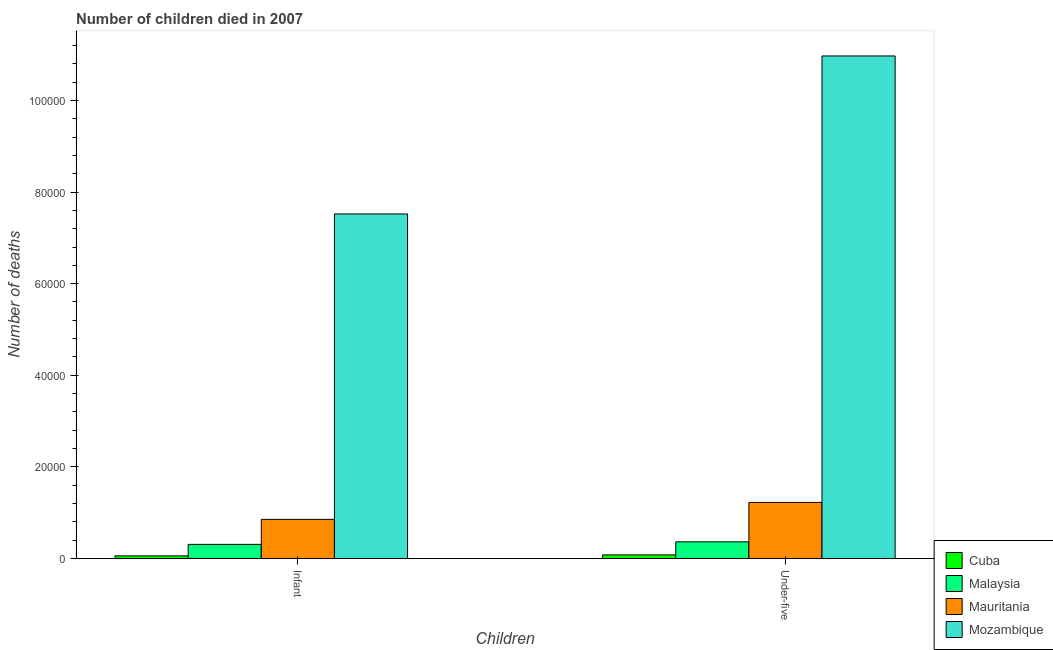Are the number of bars per tick equal to the number of legend labels?
Your answer should be very brief. Yes. What is the label of the 1st group of bars from the left?
Your answer should be very brief. Infant. What is the number of infant deaths in Cuba?
Give a very brief answer. 590. Across all countries, what is the maximum number of infant deaths?
Ensure brevity in your answer.  7.52e+04. Across all countries, what is the minimum number of infant deaths?
Keep it short and to the point. 590. In which country was the number of under-five deaths maximum?
Make the answer very short. Mozambique. In which country was the number of under-five deaths minimum?
Provide a short and direct response. Cuba. What is the total number of infant deaths in the graph?
Your response must be concise. 8.75e+04. What is the difference between the number of infant deaths in Malaysia and that in Mozambique?
Offer a very short reply. -7.21e+04. What is the difference between the number of infant deaths in Malaysia and the number of under-five deaths in Cuba?
Give a very brief answer. 2300. What is the average number of under-five deaths per country?
Give a very brief answer. 3.16e+04. What is the difference between the number of under-five deaths and number of infant deaths in Mauritania?
Offer a terse response. 3699. In how many countries, is the number of under-five deaths greater than 48000 ?
Your response must be concise. 1. What is the ratio of the number of infant deaths in Mauritania to that in Cuba?
Your response must be concise. 14.5. Is the number of infant deaths in Mauritania less than that in Cuba?
Your answer should be compact. No. In how many countries, is the number of under-five deaths greater than the average number of under-five deaths taken over all countries?
Make the answer very short. 1. What does the 1st bar from the left in Infant represents?
Keep it short and to the point. Cuba. What does the 4th bar from the right in Under-five represents?
Your answer should be very brief. Cuba. How many countries are there in the graph?
Your answer should be very brief. 4. Are the values on the major ticks of Y-axis written in scientific E-notation?
Provide a short and direct response. No. Where does the legend appear in the graph?
Give a very brief answer. Bottom right. How many legend labels are there?
Offer a terse response. 4. What is the title of the graph?
Provide a succinct answer. Number of children died in 2007. Does "Seychelles" appear as one of the legend labels in the graph?
Provide a short and direct response. No. What is the label or title of the X-axis?
Your response must be concise. Children. What is the label or title of the Y-axis?
Ensure brevity in your answer.  Number of deaths. What is the Number of deaths of Cuba in Infant?
Offer a very short reply. 590. What is the Number of deaths of Malaysia in Infant?
Keep it short and to the point. 3101. What is the Number of deaths in Mauritania in Infant?
Offer a very short reply. 8556. What is the Number of deaths of Mozambique in Infant?
Ensure brevity in your answer.  7.52e+04. What is the Number of deaths of Cuba in Under-five?
Keep it short and to the point. 801. What is the Number of deaths of Malaysia in Under-five?
Your answer should be compact. 3651. What is the Number of deaths in Mauritania in Under-five?
Offer a very short reply. 1.23e+04. What is the Number of deaths of Mozambique in Under-five?
Ensure brevity in your answer.  1.10e+05. Across all Children, what is the maximum Number of deaths of Cuba?
Your response must be concise. 801. Across all Children, what is the maximum Number of deaths in Malaysia?
Ensure brevity in your answer.  3651. Across all Children, what is the maximum Number of deaths of Mauritania?
Provide a short and direct response. 1.23e+04. Across all Children, what is the maximum Number of deaths in Mozambique?
Provide a succinct answer. 1.10e+05. Across all Children, what is the minimum Number of deaths in Cuba?
Offer a very short reply. 590. Across all Children, what is the minimum Number of deaths in Malaysia?
Keep it short and to the point. 3101. Across all Children, what is the minimum Number of deaths of Mauritania?
Your response must be concise. 8556. Across all Children, what is the minimum Number of deaths of Mozambique?
Offer a very short reply. 7.52e+04. What is the total Number of deaths in Cuba in the graph?
Your response must be concise. 1391. What is the total Number of deaths in Malaysia in the graph?
Keep it short and to the point. 6752. What is the total Number of deaths of Mauritania in the graph?
Offer a very short reply. 2.08e+04. What is the total Number of deaths in Mozambique in the graph?
Your answer should be compact. 1.85e+05. What is the difference between the Number of deaths of Cuba in Infant and that in Under-five?
Keep it short and to the point. -211. What is the difference between the Number of deaths of Malaysia in Infant and that in Under-five?
Provide a succinct answer. -550. What is the difference between the Number of deaths of Mauritania in Infant and that in Under-five?
Give a very brief answer. -3699. What is the difference between the Number of deaths of Mozambique in Infant and that in Under-five?
Give a very brief answer. -3.45e+04. What is the difference between the Number of deaths in Cuba in Infant and the Number of deaths in Malaysia in Under-five?
Ensure brevity in your answer.  -3061. What is the difference between the Number of deaths of Cuba in Infant and the Number of deaths of Mauritania in Under-five?
Offer a very short reply. -1.17e+04. What is the difference between the Number of deaths in Cuba in Infant and the Number of deaths in Mozambique in Under-five?
Give a very brief answer. -1.09e+05. What is the difference between the Number of deaths in Malaysia in Infant and the Number of deaths in Mauritania in Under-five?
Your answer should be very brief. -9154. What is the difference between the Number of deaths of Malaysia in Infant and the Number of deaths of Mozambique in Under-five?
Offer a very short reply. -1.07e+05. What is the difference between the Number of deaths of Mauritania in Infant and the Number of deaths of Mozambique in Under-five?
Your response must be concise. -1.01e+05. What is the average Number of deaths of Cuba per Children?
Make the answer very short. 695.5. What is the average Number of deaths in Malaysia per Children?
Give a very brief answer. 3376. What is the average Number of deaths in Mauritania per Children?
Provide a short and direct response. 1.04e+04. What is the average Number of deaths in Mozambique per Children?
Make the answer very short. 9.25e+04. What is the difference between the Number of deaths in Cuba and Number of deaths in Malaysia in Infant?
Your answer should be very brief. -2511. What is the difference between the Number of deaths in Cuba and Number of deaths in Mauritania in Infant?
Your answer should be compact. -7966. What is the difference between the Number of deaths in Cuba and Number of deaths in Mozambique in Infant?
Offer a terse response. -7.46e+04. What is the difference between the Number of deaths of Malaysia and Number of deaths of Mauritania in Infant?
Provide a succinct answer. -5455. What is the difference between the Number of deaths of Malaysia and Number of deaths of Mozambique in Infant?
Give a very brief answer. -7.21e+04. What is the difference between the Number of deaths of Mauritania and Number of deaths of Mozambique in Infant?
Your answer should be very brief. -6.67e+04. What is the difference between the Number of deaths of Cuba and Number of deaths of Malaysia in Under-five?
Provide a short and direct response. -2850. What is the difference between the Number of deaths in Cuba and Number of deaths in Mauritania in Under-five?
Offer a terse response. -1.15e+04. What is the difference between the Number of deaths of Cuba and Number of deaths of Mozambique in Under-five?
Keep it short and to the point. -1.09e+05. What is the difference between the Number of deaths in Malaysia and Number of deaths in Mauritania in Under-five?
Keep it short and to the point. -8604. What is the difference between the Number of deaths in Malaysia and Number of deaths in Mozambique in Under-five?
Offer a very short reply. -1.06e+05. What is the difference between the Number of deaths of Mauritania and Number of deaths of Mozambique in Under-five?
Your response must be concise. -9.74e+04. What is the ratio of the Number of deaths in Cuba in Infant to that in Under-five?
Make the answer very short. 0.74. What is the ratio of the Number of deaths in Malaysia in Infant to that in Under-five?
Keep it short and to the point. 0.85. What is the ratio of the Number of deaths in Mauritania in Infant to that in Under-five?
Your answer should be compact. 0.7. What is the ratio of the Number of deaths in Mozambique in Infant to that in Under-five?
Keep it short and to the point. 0.69. What is the difference between the highest and the second highest Number of deaths of Cuba?
Offer a very short reply. 211. What is the difference between the highest and the second highest Number of deaths of Malaysia?
Keep it short and to the point. 550. What is the difference between the highest and the second highest Number of deaths in Mauritania?
Provide a short and direct response. 3699. What is the difference between the highest and the second highest Number of deaths of Mozambique?
Your response must be concise. 3.45e+04. What is the difference between the highest and the lowest Number of deaths in Cuba?
Keep it short and to the point. 211. What is the difference between the highest and the lowest Number of deaths in Malaysia?
Your response must be concise. 550. What is the difference between the highest and the lowest Number of deaths of Mauritania?
Ensure brevity in your answer.  3699. What is the difference between the highest and the lowest Number of deaths of Mozambique?
Keep it short and to the point. 3.45e+04. 